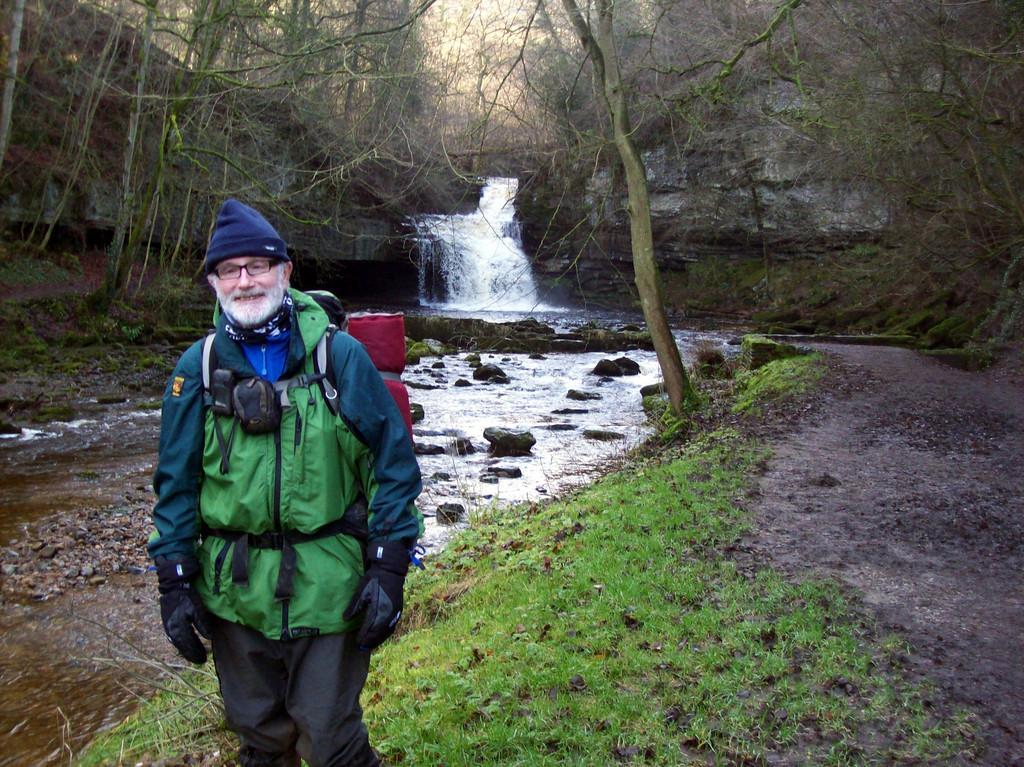Can you describe this image briefly? In this picture we can see a man in the coat is standing on the grass path. Behind the man there is waterfall, stones, trees and a hill. 